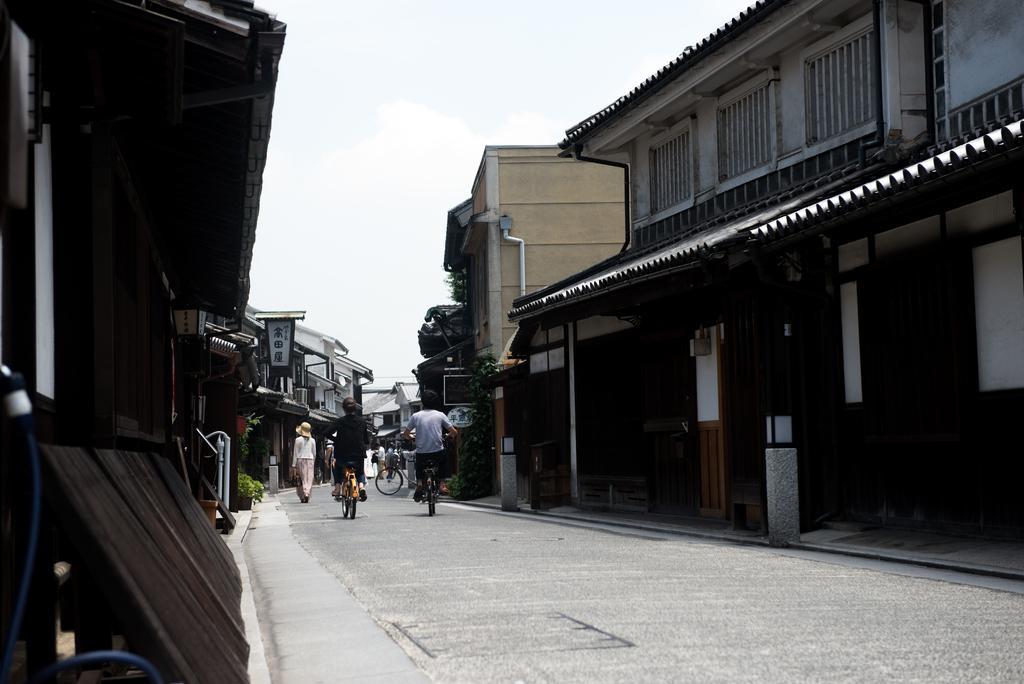In one or two sentences, can you explain what this image depicts? Here people are riding bicycles on the road, a woman is walking, here there are houses with the windows, this is sky. 